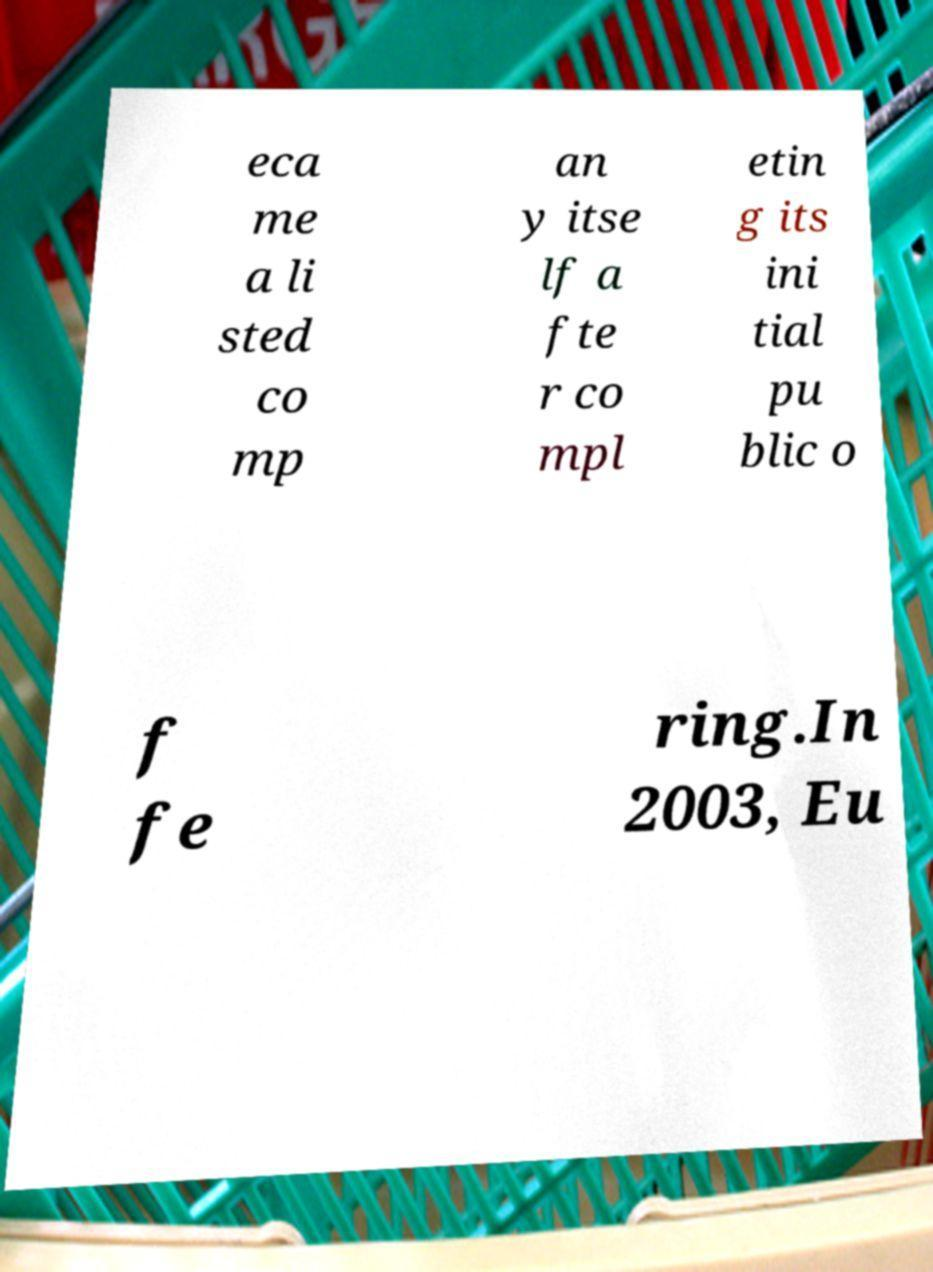There's text embedded in this image that I need extracted. Can you transcribe it verbatim? eca me a li sted co mp an y itse lf a fte r co mpl etin g its ini tial pu blic o f fe ring.In 2003, Eu 